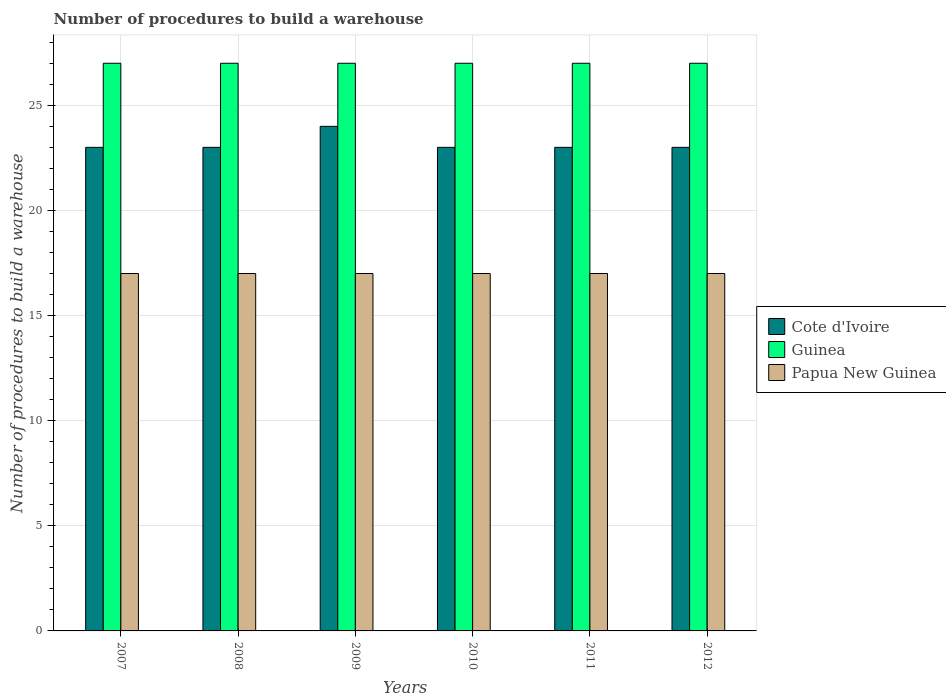How many groups of bars are there?
Provide a succinct answer. 6. Are the number of bars per tick equal to the number of legend labels?
Ensure brevity in your answer.  Yes. Are the number of bars on each tick of the X-axis equal?
Ensure brevity in your answer.  Yes. How many bars are there on the 6th tick from the left?
Make the answer very short. 3. How many bars are there on the 3rd tick from the right?
Make the answer very short. 3. What is the label of the 1st group of bars from the left?
Your answer should be compact. 2007. In how many cases, is the number of bars for a given year not equal to the number of legend labels?
Ensure brevity in your answer.  0. What is the number of procedures to build a warehouse in in Papua New Guinea in 2011?
Offer a terse response. 17. Across all years, what is the maximum number of procedures to build a warehouse in in Papua New Guinea?
Your response must be concise. 17. Across all years, what is the minimum number of procedures to build a warehouse in in Guinea?
Offer a terse response. 27. In which year was the number of procedures to build a warehouse in in Papua New Guinea maximum?
Offer a very short reply. 2007. What is the total number of procedures to build a warehouse in in Cote d'Ivoire in the graph?
Provide a succinct answer. 139. What is the difference between the number of procedures to build a warehouse in in Cote d'Ivoire in 2008 and that in 2009?
Make the answer very short. -1. What is the difference between the number of procedures to build a warehouse in in Cote d'Ivoire in 2007 and the number of procedures to build a warehouse in in Papua New Guinea in 2011?
Provide a succinct answer. 6. In the year 2012, what is the difference between the number of procedures to build a warehouse in in Guinea and number of procedures to build a warehouse in in Papua New Guinea?
Your response must be concise. 10. In how many years, is the number of procedures to build a warehouse in in Cote d'Ivoire greater than 23?
Offer a terse response. 1. Is the difference between the number of procedures to build a warehouse in in Guinea in 2007 and 2011 greater than the difference between the number of procedures to build a warehouse in in Papua New Guinea in 2007 and 2011?
Your answer should be very brief. No. What is the difference between the highest and the lowest number of procedures to build a warehouse in in Cote d'Ivoire?
Your answer should be compact. 1. Is the sum of the number of procedures to build a warehouse in in Papua New Guinea in 2008 and 2012 greater than the maximum number of procedures to build a warehouse in in Cote d'Ivoire across all years?
Give a very brief answer. Yes. What does the 1st bar from the left in 2007 represents?
Offer a terse response. Cote d'Ivoire. What does the 1st bar from the right in 2009 represents?
Offer a very short reply. Papua New Guinea. How many bars are there?
Give a very brief answer. 18. Are all the bars in the graph horizontal?
Your answer should be very brief. No. How many years are there in the graph?
Ensure brevity in your answer.  6. Are the values on the major ticks of Y-axis written in scientific E-notation?
Your response must be concise. No. Does the graph contain any zero values?
Provide a short and direct response. No. Does the graph contain grids?
Give a very brief answer. Yes. How many legend labels are there?
Your answer should be compact. 3. How are the legend labels stacked?
Your answer should be compact. Vertical. What is the title of the graph?
Ensure brevity in your answer.  Number of procedures to build a warehouse. What is the label or title of the Y-axis?
Your response must be concise. Number of procedures to build a warehouse. What is the Number of procedures to build a warehouse of Cote d'Ivoire in 2008?
Ensure brevity in your answer.  23. What is the Number of procedures to build a warehouse in Cote d'Ivoire in 2009?
Your answer should be very brief. 24. What is the Number of procedures to build a warehouse in Papua New Guinea in 2009?
Your response must be concise. 17. What is the Number of procedures to build a warehouse in Cote d'Ivoire in 2010?
Offer a very short reply. 23. What is the Number of procedures to build a warehouse in Cote d'Ivoire in 2011?
Make the answer very short. 23. What is the Number of procedures to build a warehouse of Papua New Guinea in 2011?
Ensure brevity in your answer.  17. What is the Number of procedures to build a warehouse in Cote d'Ivoire in 2012?
Your answer should be very brief. 23. What is the Number of procedures to build a warehouse in Guinea in 2012?
Your answer should be compact. 27. What is the Number of procedures to build a warehouse of Papua New Guinea in 2012?
Give a very brief answer. 17. Across all years, what is the maximum Number of procedures to build a warehouse of Cote d'Ivoire?
Make the answer very short. 24. Across all years, what is the maximum Number of procedures to build a warehouse of Guinea?
Make the answer very short. 27. Across all years, what is the minimum Number of procedures to build a warehouse of Cote d'Ivoire?
Give a very brief answer. 23. Across all years, what is the minimum Number of procedures to build a warehouse of Guinea?
Give a very brief answer. 27. Across all years, what is the minimum Number of procedures to build a warehouse in Papua New Guinea?
Your answer should be compact. 17. What is the total Number of procedures to build a warehouse of Cote d'Ivoire in the graph?
Offer a very short reply. 139. What is the total Number of procedures to build a warehouse in Guinea in the graph?
Ensure brevity in your answer.  162. What is the total Number of procedures to build a warehouse in Papua New Guinea in the graph?
Provide a short and direct response. 102. What is the difference between the Number of procedures to build a warehouse of Cote d'Ivoire in 2007 and that in 2008?
Provide a succinct answer. 0. What is the difference between the Number of procedures to build a warehouse of Guinea in 2007 and that in 2008?
Offer a terse response. 0. What is the difference between the Number of procedures to build a warehouse in Papua New Guinea in 2007 and that in 2008?
Your answer should be compact. 0. What is the difference between the Number of procedures to build a warehouse in Cote d'Ivoire in 2007 and that in 2009?
Give a very brief answer. -1. What is the difference between the Number of procedures to build a warehouse of Papua New Guinea in 2007 and that in 2009?
Make the answer very short. 0. What is the difference between the Number of procedures to build a warehouse of Papua New Guinea in 2007 and that in 2010?
Your response must be concise. 0. What is the difference between the Number of procedures to build a warehouse of Cote d'Ivoire in 2007 and that in 2011?
Give a very brief answer. 0. What is the difference between the Number of procedures to build a warehouse of Papua New Guinea in 2007 and that in 2011?
Ensure brevity in your answer.  0. What is the difference between the Number of procedures to build a warehouse of Cote d'Ivoire in 2007 and that in 2012?
Offer a terse response. 0. What is the difference between the Number of procedures to build a warehouse of Papua New Guinea in 2007 and that in 2012?
Provide a succinct answer. 0. What is the difference between the Number of procedures to build a warehouse of Papua New Guinea in 2008 and that in 2009?
Provide a succinct answer. 0. What is the difference between the Number of procedures to build a warehouse in Cote d'Ivoire in 2008 and that in 2010?
Your answer should be compact. 0. What is the difference between the Number of procedures to build a warehouse of Guinea in 2008 and that in 2010?
Keep it short and to the point. 0. What is the difference between the Number of procedures to build a warehouse of Papua New Guinea in 2008 and that in 2011?
Keep it short and to the point. 0. What is the difference between the Number of procedures to build a warehouse of Guinea in 2008 and that in 2012?
Offer a very short reply. 0. What is the difference between the Number of procedures to build a warehouse of Cote d'Ivoire in 2009 and that in 2010?
Provide a succinct answer. 1. What is the difference between the Number of procedures to build a warehouse in Guinea in 2009 and that in 2010?
Make the answer very short. 0. What is the difference between the Number of procedures to build a warehouse in Cote d'Ivoire in 2009 and that in 2011?
Provide a short and direct response. 1. What is the difference between the Number of procedures to build a warehouse in Guinea in 2009 and that in 2011?
Your answer should be very brief. 0. What is the difference between the Number of procedures to build a warehouse of Papua New Guinea in 2009 and that in 2011?
Your answer should be very brief. 0. What is the difference between the Number of procedures to build a warehouse in Cote d'Ivoire in 2010 and that in 2012?
Offer a terse response. 0. What is the difference between the Number of procedures to build a warehouse in Papua New Guinea in 2010 and that in 2012?
Give a very brief answer. 0. What is the difference between the Number of procedures to build a warehouse of Cote d'Ivoire in 2011 and that in 2012?
Provide a short and direct response. 0. What is the difference between the Number of procedures to build a warehouse in Papua New Guinea in 2011 and that in 2012?
Your answer should be compact. 0. What is the difference between the Number of procedures to build a warehouse of Cote d'Ivoire in 2007 and the Number of procedures to build a warehouse of Papua New Guinea in 2008?
Provide a short and direct response. 6. What is the difference between the Number of procedures to build a warehouse of Guinea in 2007 and the Number of procedures to build a warehouse of Papua New Guinea in 2008?
Your response must be concise. 10. What is the difference between the Number of procedures to build a warehouse of Cote d'Ivoire in 2007 and the Number of procedures to build a warehouse of Guinea in 2009?
Provide a short and direct response. -4. What is the difference between the Number of procedures to build a warehouse in Guinea in 2007 and the Number of procedures to build a warehouse in Papua New Guinea in 2009?
Your answer should be compact. 10. What is the difference between the Number of procedures to build a warehouse of Cote d'Ivoire in 2007 and the Number of procedures to build a warehouse of Guinea in 2010?
Provide a short and direct response. -4. What is the difference between the Number of procedures to build a warehouse in Cote d'Ivoire in 2007 and the Number of procedures to build a warehouse in Papua New Guinea in 2010?
Give a very brief answer. 6. What is the difference between the Number of procedures to build a warehouse of Guinea in 2007 and the Number of procedures to build a warehouse of Papua New Guinea in 2010?
Give a very brief answer. 10. What is the difference between the Number of procedures to build a warehouse in Cote d'Ivoire in 2007 and the Number of procedures to build a warehouse in Guinea in 2011?
Offer a very short reply. -4. What is the difference between the Number of procedures to build a warehouse of Cote d'Ivoire in 2007 and the Number of procedures to build a warehouse of Papua New Guinea in 2011?
Your response must be concise. 6. What is the difference between the Number of procedures to build a warehouse in Cote d'Ivoire in 2007 and the Number of procedures to build a warehouse in Guinea in 2012?
Give a very brief answer. -4. What is the difference between the Number of procedures to build a warehouse in Guinea in 2007 and the Number of procedures to build a warehouse in Papua New Guinea in 2012?
Your response must be concise. 10. What is the difference between the Number of procedures to build a warehouse in Guinea in 2008 and the Number of procedures to build a warehouse in Papua New Guinea in 2009?
Your answer should be very brief. 10. What is the difference between the Number of procedures to build a warehouse of Guinea in 2008 and the Number of procedures to build a warehouse of Papua New Guinea in 2010?
Keep it short and to the point. 10. What is the difference between the Number of procedures to build a warehouse in Guinea in 2008 and the Number of procedures to build a warehouse in Papua New Guinea in 2011?
Provide a succinct answer. 10. What is the difference between the Number of procedures to build a warehouse of Cote d'Ivoire in 2008 and the Number of procedures to build a warehouse of Guinea in 2012?
Ensure brevity in your answer.  -4. What is the difference between the Number of procedures to build a warehouse of Guinea in 2008 and the Number of procedures to build a warehouse of Papua New Guinea in 2012?
Your response must be concise. 10. What is the difference between the Number of procedures to build a warehouse in Cote d'Ivoire in 2009 and the Number of procedures to build a warehouse in Guinea in 2010?
Your answer should be very brief. -3. What is the difference between the Number of procedures to build a warehouse of Cote d'Ivoire in 2009 and the Number of procedures to build a warehouse of Papua New Guinea in 2010?
Your answer should be very brief. 7. What is the difference between the Number of procedures to build a warehouse in Cote d'Ivoire in 2009 and the Number of procedures to build a warehouse in Guinea in 2011?
Your answer should be very brief. -3. What is the difference between the Number of procedures to build a warehouse in Cote d'Ivoire in 2009 and the Number of procedures to build a warehouse in Papua New Guinea in 2012?
Your answer should be compact. 7. What is the difference between the Number of procedures to build a warehouse in Guinea in 2009 and the Number of procedures to build a warehouse in Papua New Guinea in 2012?
Provide a succinct answer. 10. What is the difference between the Number of procedures to build a warehouse of Cote d'Ivoire in 2010 and the Number of procedures to build a warehouse of Guinea in 2011?
Provide a succinct answer. -4. What is the difference between the Number of procedures to build a warehouse of Cote d'Ivoire in 2010 and the Number of procedures to build a warehouse of Papua New Guinea in 2011?
Ensure brevity in your answer.  6. What is the difference between the Number of procedures to build a warehouse in Guinea in 2010 and the Number of procedures to build a warehouse in Papua New Guinea in 2011?
Offer a terse response. 10. What is the difference between the Number of procedures to build a warehouse of Cote d'Ivoire in 2010 and the Number of procedures to build a warehouse of Guinea in 2012?
Provide a succinct answer. -4. What is the difference between the Number of procedures to build a warehouse of Guinea in 2011 and the Number of procedures to build a warehouse of Papua New Guinea in 2012?
Give a very brief answer. 10. What is the average Number of procedures to build a warehouse in Cote d'Ivoire per year?
Keep it short and to the point. 23.17. What is the average Number of procedures to build a warehouse of Guinea per year?
Give a very brief answer. 27. In the year 2007, what is the difference between the Number of procedures to build a warehouse of Cote d'Ivoire and Number of procedures to build a warehouse of Papua New Guinea?
Your answer should be compact. 6. In the year 2008, what is the difference between the Number of procedures to build a warehouse in Cote d'Ivoire and Number of procedures to build a warehouse in Guinea?
Offer a very short reply. -4. In the year 2009, what is the difference between the Number of procedures to build a warehouse in Cote d'Ivoire and Number of procedures to build a warehouse in Guinea?
Ensure brevity in your answer.  -3. In the year 2009, what is the difference between the Number of procedures to build a warehouse of Guinea and Number of procedures to build a warehouse of Papua New Guinea?
Your answer should be compact. 10. In the year 2010, what is the difference between the Number of procedures to build a warehouse of Cote d'Ivoire and Number of procedures to build a warehouse of Papua New Guinea?
Ensure brevity in your answer.  6. In the year 2011, what is the difference between the Number of procedures to build a warehouse in Cote d'Ivoire and Number of procedures to build a warehouse in Guinea?
Offer a terse response. -4. In the year 2011, what is the difference between the Number of procedures to build a warehouse in Cote d'Ivoire and Number of procedures to build a warehouse in Papua New Guinea?
Keep it short and to the point. 6. In the year 2011, what is the difference between the Number of procedures to build a warehouse of Guinea and Number of procedures to build a warehouse of Papua New Guinea?
Give a very brief answer. 10. In the year 2012, what is the difference between the Number of procedures to build a warehouse of Cote d'Ivoire and Number of procedures to build a warehouse of Guinea?
Provide a succinct answer. -4. In the year 2012, what is the difference between the Number of procedures to build a warehouse of Cote d'Ivoire and Number of procedures to build a warehouse of Papua New Guinea?
Your response must be concise. 6. In the year 2012, what is the difference between the Number of procedures to build a warehouse of Guinea and Number of procedures to build a warehouse of Papua New Guinea?
Give a very brief answer. 10. What is the ratio of the Number of procedures to build a warehouse in Cote d'Ivoire in 2007 to that in 2008?
Give a very brief answer. 1. What is the ratio of the Number of procedures to build a warehouse of Guinea in 2007 to that in 2008?
Provide a short and direct response. 1. What is the ratio of the Number of procedures to build a warehouse in Cote d'Ivoire in 2007 to that in 2009?
Provide a short and direct response. 0.96. What is the ratio of the Number of procedures to build a warehouse in Cote d'Ivoire in 2007 to that in 2010?
Keep it short and to the point. 1. What is the ratio of the Number of procedures to build a warehouse in Guinea in 2007 to that in 2010?
Offer a terse response. 1. What is the ratio of the Number of procedures to build a warehouse in Papua New Guinea in 2007 to that in 2010?
Offer a very short reply. 1. What is the ratio of the Number of procedures to build a warehouse of Guinea in 2007 to that in 2011?
Your answer should be very brief. 1. What is the ratio of the Number of procedures to build a warehouse of Guinea in 2007 to that in 2012?
Give a very brief answer. 1. What is the ratio of the Number of procedures to build a warehouse in Cote d'Ivoire in 2008 to that in 2009?
Provide a short and direct response. 0.96. What is the ratio of the Number of procedures to build a warehouse of Guinea in 2008 to that in 2009?
Give a very brief answer. 1. What is the ratio of the Number of procedures to build a warehouse of Papua New Guinea in 2008 to that in 2009?
Make the answer very short. 1. What is the ratio of the Number of procedures to build a warehouse in Cote d'Ivoire in 2008 to that in 2010?
Ensure brevity in your answer.  1. What is the ratio of the Number of procedures to build a warehouse of Papua New Guinea in 2008 to that in 2012?
Provide a succinct answer. 1. What is the ratio of the Number of procedures to build a warehouse of Cote d'Ivoire in 2009 to that in 2010?
Offer a terse response. 1.04. What is the ratio of the Number of procedures to build a warehouse in Cote d'Ivoire in 2009 to that in 2011?
Offer a terse response. 1.04. What is the ratio of the Number of procedures to build a warehouse in Papua New Guinea in 2009 to that in 2011?
Offer a terse response. 1. What is the ratio of the Number of procedures to build a warehouse in Cote d'Ivoire in 2009 to that in 2012?
Make the answer very short. 1.04. What is the ratio of the Number of procedures to build a warehouse in Guinea in 2009 to that in 2012?
Keep it short and to the point. 1. What is the ratio of the Number of procedures to build a warehouse of Papua New Guinea in 2010 to that in 2011?
Give a very brief answer. 1. What is the ratio of the Number of procedures to build a warehouse in Cote d'Ivoire in 2010 to that in 2012?
Make the answer very short. 1. What is the ratio of the Number of procedures to build a warehouse in Guinea in 2010 to that in 2012?
Offer a terse response. 1. What is the ratio of the Number of procedures to build a warehouse in Guinea in 2011 to that in 2012?
Give a very brief answer. 1. What is the ratio of the Number of procedures to build a warehouse of Papua New Guinea in 2011 to that in 2012?
Provide a succinct answer. 1. What is the difference between the highest and the second highest Number of procedures to build a warehouse in Cote d'Ivoire?
Your answer should be very brief. 1. What is the difference between the highest and the lowest Number of procedures to build a warehouse in Cote d'Ivoire?
Your response must be concise. 1. What is the difference between the highest and the lowest Number of procedures to build a warehouse of Guinea?
Keep it short and to the point. 0. 